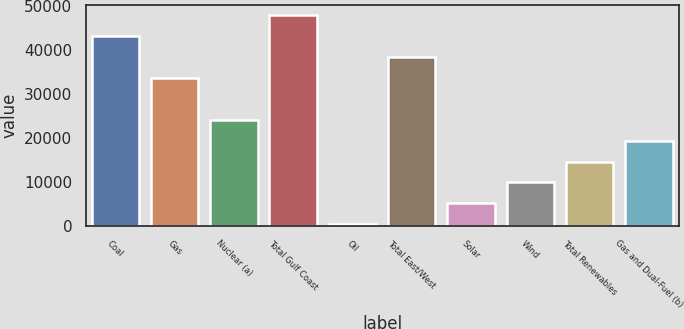Convert chart. <chart><loc_0><loc_0><loc_500><loc_500><bar_chart><fcel>Coal<fcel>Gas<fcel>Nuclear (a)<fcel>Total Gulf Coast<fcel>Oil<fcel>Total East/West<fcel>Solar<fcel>Wind<fcel>Total Renewables<fcel>Gas and Dual-Fuel (b)<nl><fcel>43076.1<fcel>33574.3<fcel>24072.5<fcel>47827<fcel>318<fcel>38325.2<fcel>5068.9<fcel>9819.8<fcel>14570.7<fcel>19321.6<nl></chart> 